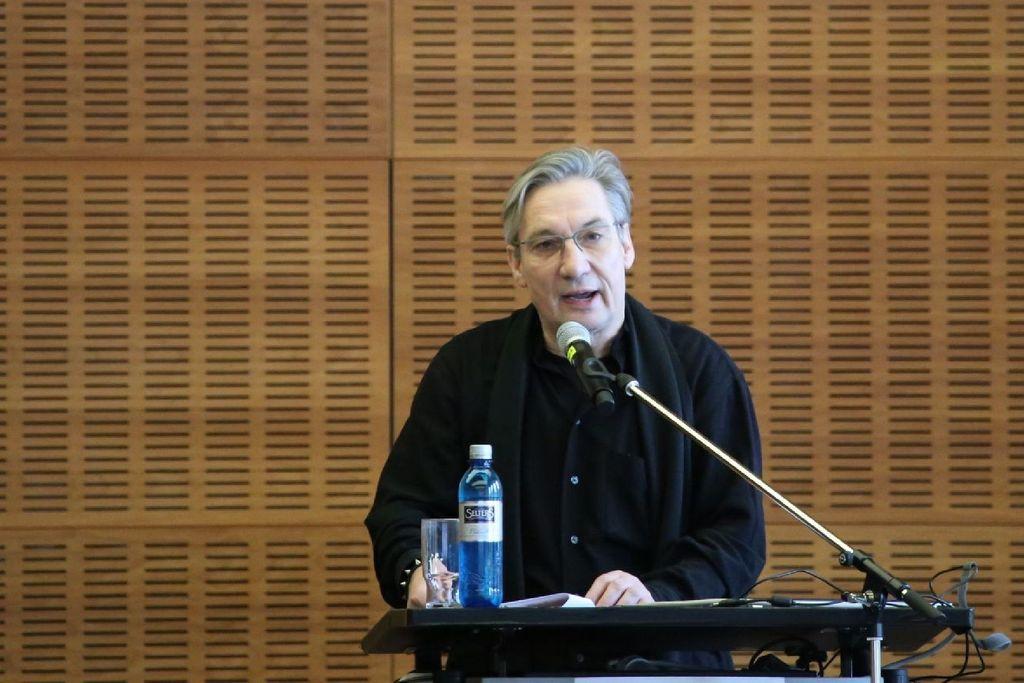Could you give a brief overview of what you see in this image? In the center of the image there is a person standing at lectern with mic. On the lectern we can see papers, bottle and glass. In the background there is a wall. 